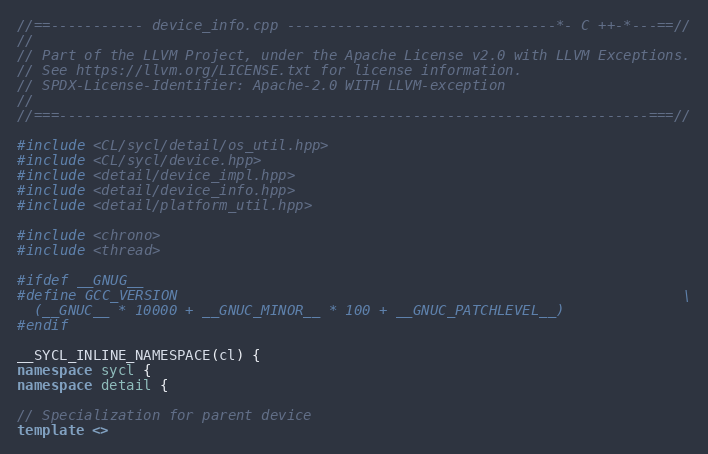<code> <loc_0><loc_0><loc_500><loc_500><_C++_>//==----------- device_info.cpp --------------------------------*- C ++-*---==//
//
// Part of the LLVM Project, under the Apache License v2.0 with LLVM Exceptions.
// See https://llvm.org/LICENSE.txt for license information.
// SPDX-License-Identifier: Apache-2.0 WITH LLVM-exception
//
//===----------------------------------------------------------------------===//

#include <CL/sycl/detail/os_util.hpp>
#include <CL/sycl/device.hpp>
#include <detail/device_impl.hpp>
#include <detail/device_info.hpp>
#include <detail/platform_util.hpp>

#include <chrono>
#include <thread>

#ifdef __GNUG__
#define GCC_VERSION                                                            \
  (__GNUC__ * 10000 + __GNUC_MINOR__ * 100 + __GNUC_PATCHLEVEL__)
#endif

__SYCL_INLINE_NAMESPACE(cl) {
namespace sycl {
namespace detail {

// Specialization for parent device
template <></code> 